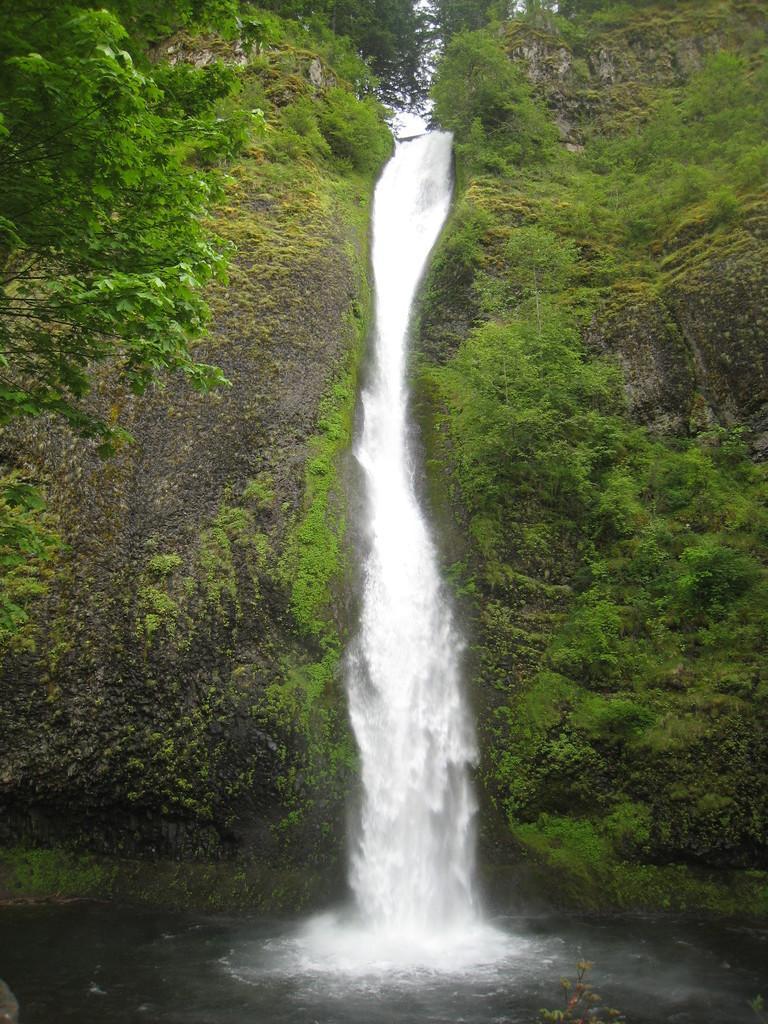Describe this image in one or two sentences. In the picture we can see a forest area with rocky hill and to it we can see, full of mold and some plants and in the middle of the hill we can see water falls and beside the hill we can see a part of the tree. 